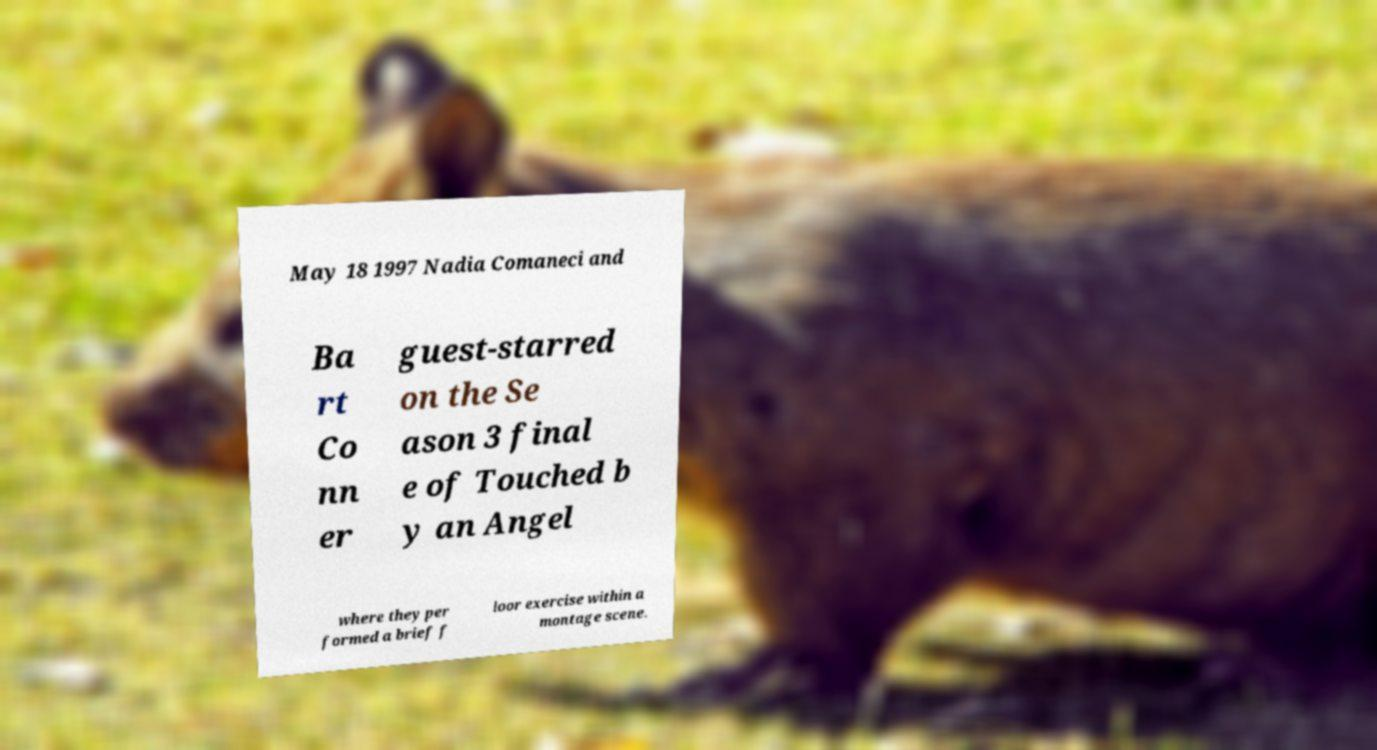There's text embedded in this image that I need extracted. Can you transcribe it verbatim? May 18 1997 Nadia Comaneci and Ba rt Co nn er guest-starred on the Se ason 3 final e of Touched b y an Angel where they per formed a brief f loor exercise within a montage scene. 